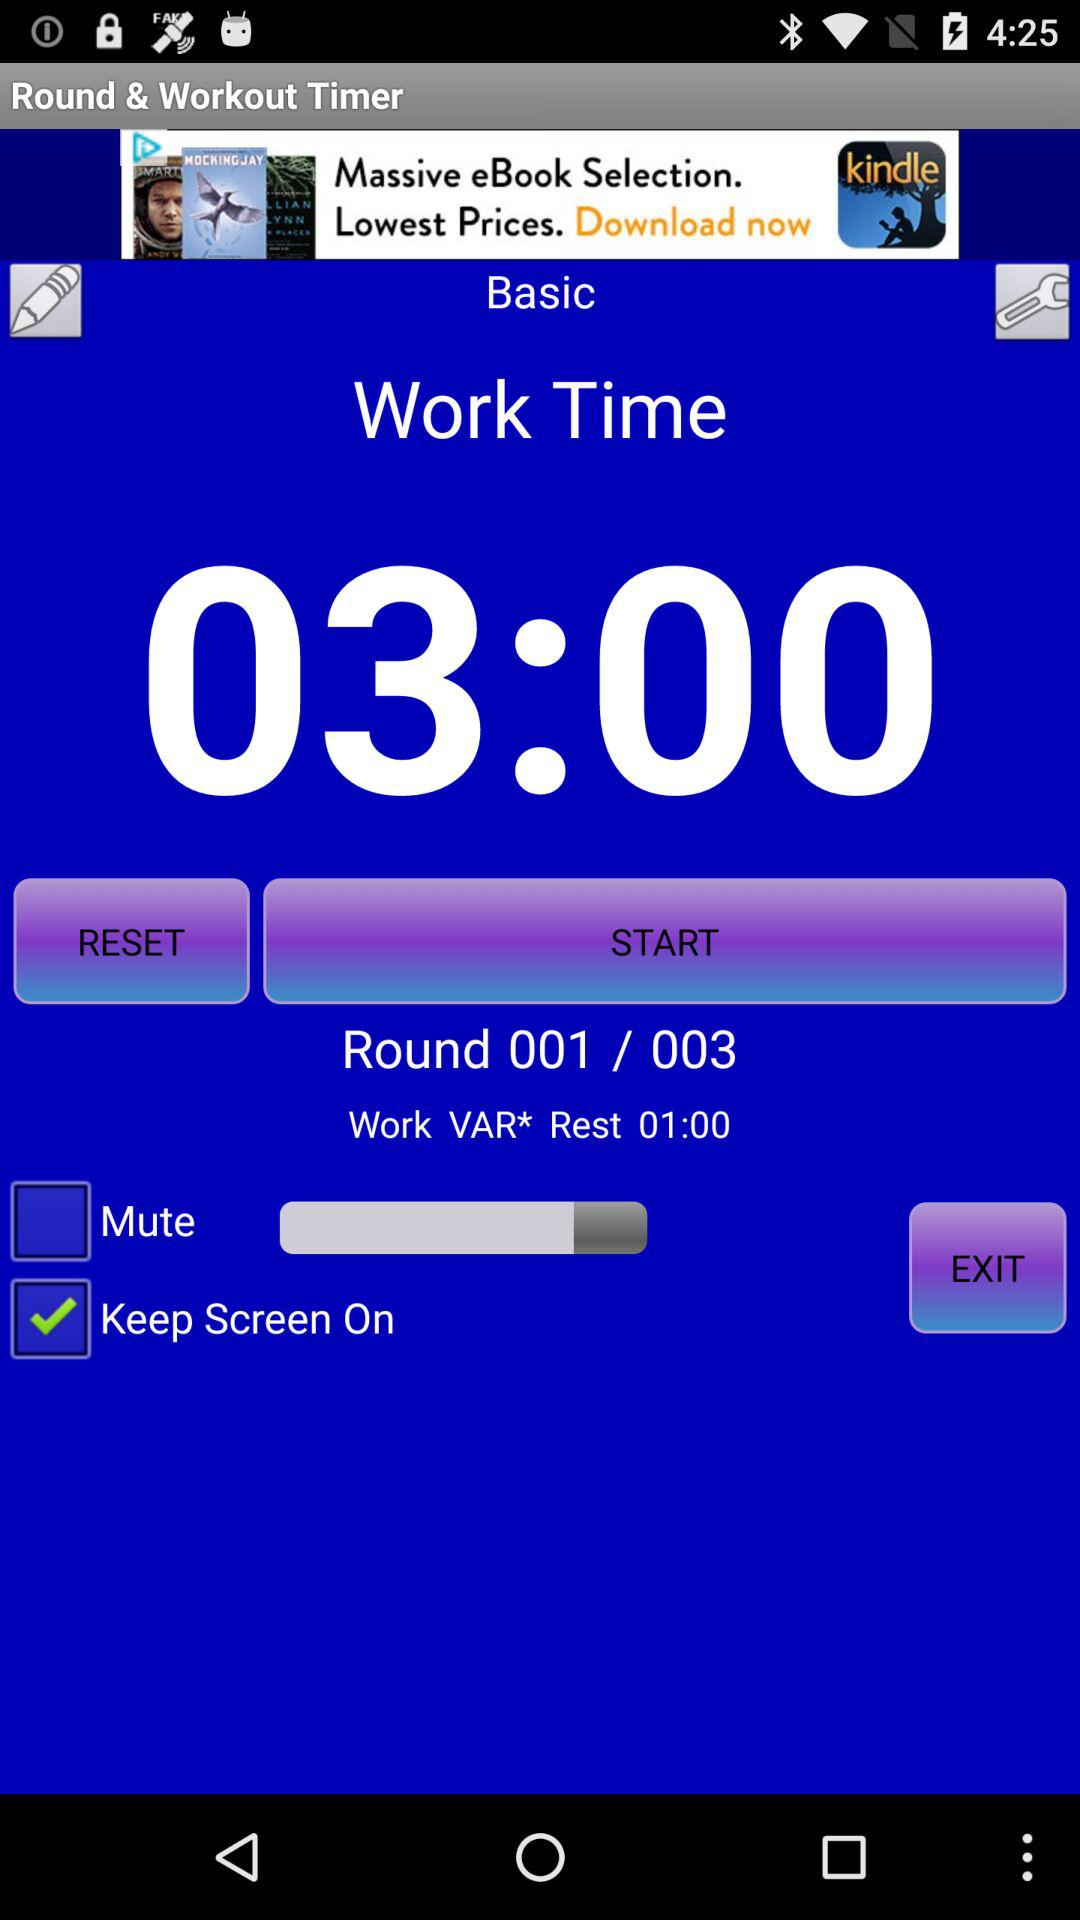What is the shown work time? The shown work time is 03:00. 